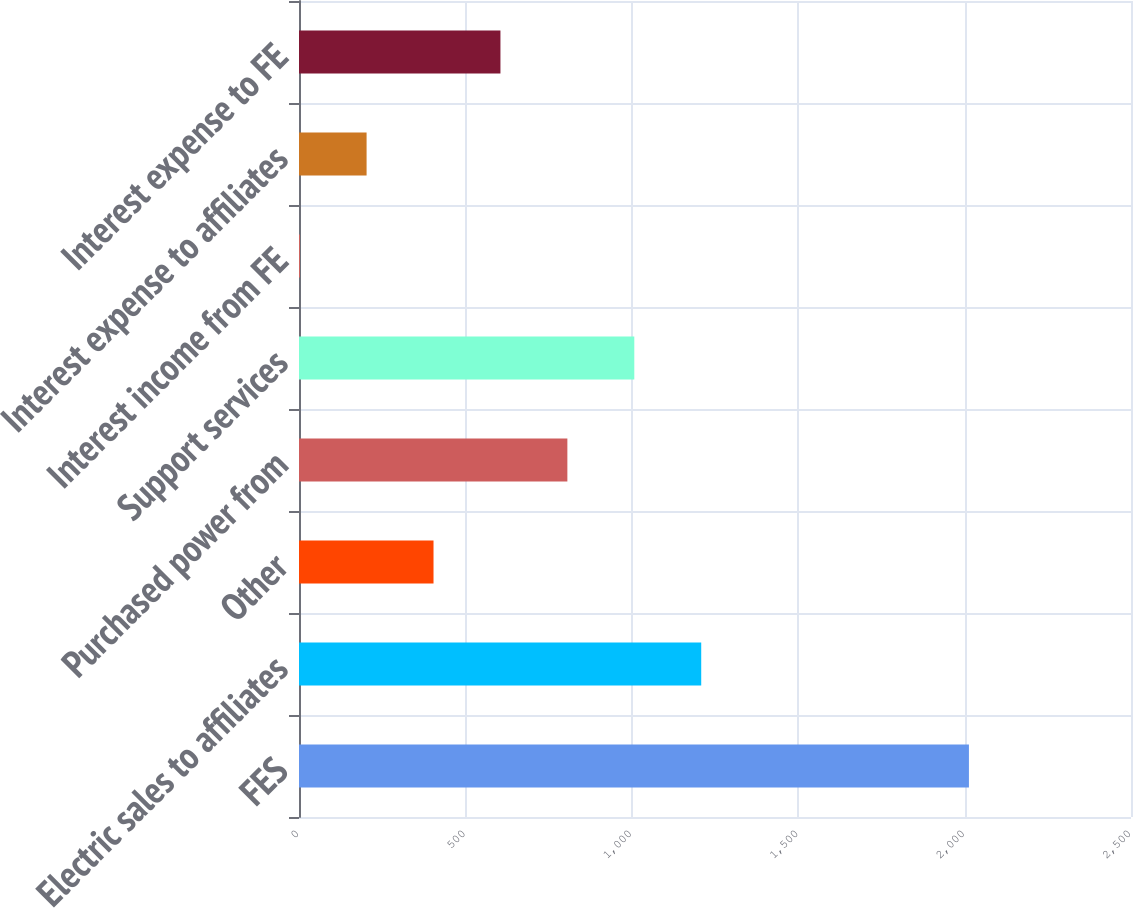Convert chart. <chart><loc_0><loc_0><loc_500><loc_500><bar_chart><fcel>FES<fcel>Electric sales to affiliates<fcel>Other<fcel>Purchased power from<fcel>Support services<fcel>Interest income from FE<fcel>Interest expense to affiliates<fcel>Interest expense to FE<nl><fcel>2013<fcel>1208.6<fcel>404.2<fcel>806.4<fcel>1007.5<fcel>2<fcel>203.1<fcel>605.3<nl></chart> 